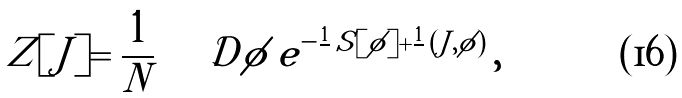<formula> <loc_0><loc_0><loc_500><loc_500>Z [ J ] = \frac { 1 } { N } \int \mathcal { D } \phi \, e ^ { - \frac { 1 } { } \, S [ \phi ] + \frac { 1 } { } \, ( J , \phi ) } \, ,</formula> 